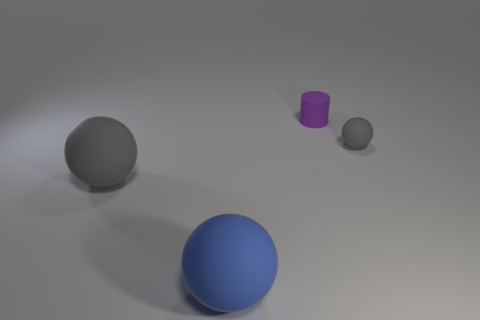The blue ball that is made of the same material as the small purple object is what size?
Your answer should be compact. Large. What number of other blue rubber things have the same shape as the blue rubber thing?
Provide a succinct answer. 0. How many things are either big blue rubber objects that are left of the small matte ball or rubber things that are on the left side of the small ball?
Your answer should be very brief. 3. There is a gray sphere left of the small rubber cylinder; what number of tiny things are right of it?
Give a very brief answer. 2. There is a gray matte object that is to the left of the blue object; does it have the same shape as the gray matte object right of the tiny cylinder?
Offer a very short reply. Yes. Are there any small red balls that have the same material as the purple cylinder?
Ensure brevity in your answer.  No. What number of metallic objects are small gray things or large blue cylinders?
Your answer should be very brief. 0. The tiny purple rubber thing behind the gray matte ball in front of the tiny gray ball is what shape?
Your response must be concise. Cylinder. Is the number of rubber objects left of the big blue matte ball less than the number of tiny gray spheres?
Give a very brief answer. No. There is a small purple matte thing; what shape is it?
Offer a terse response. Cylinder. 